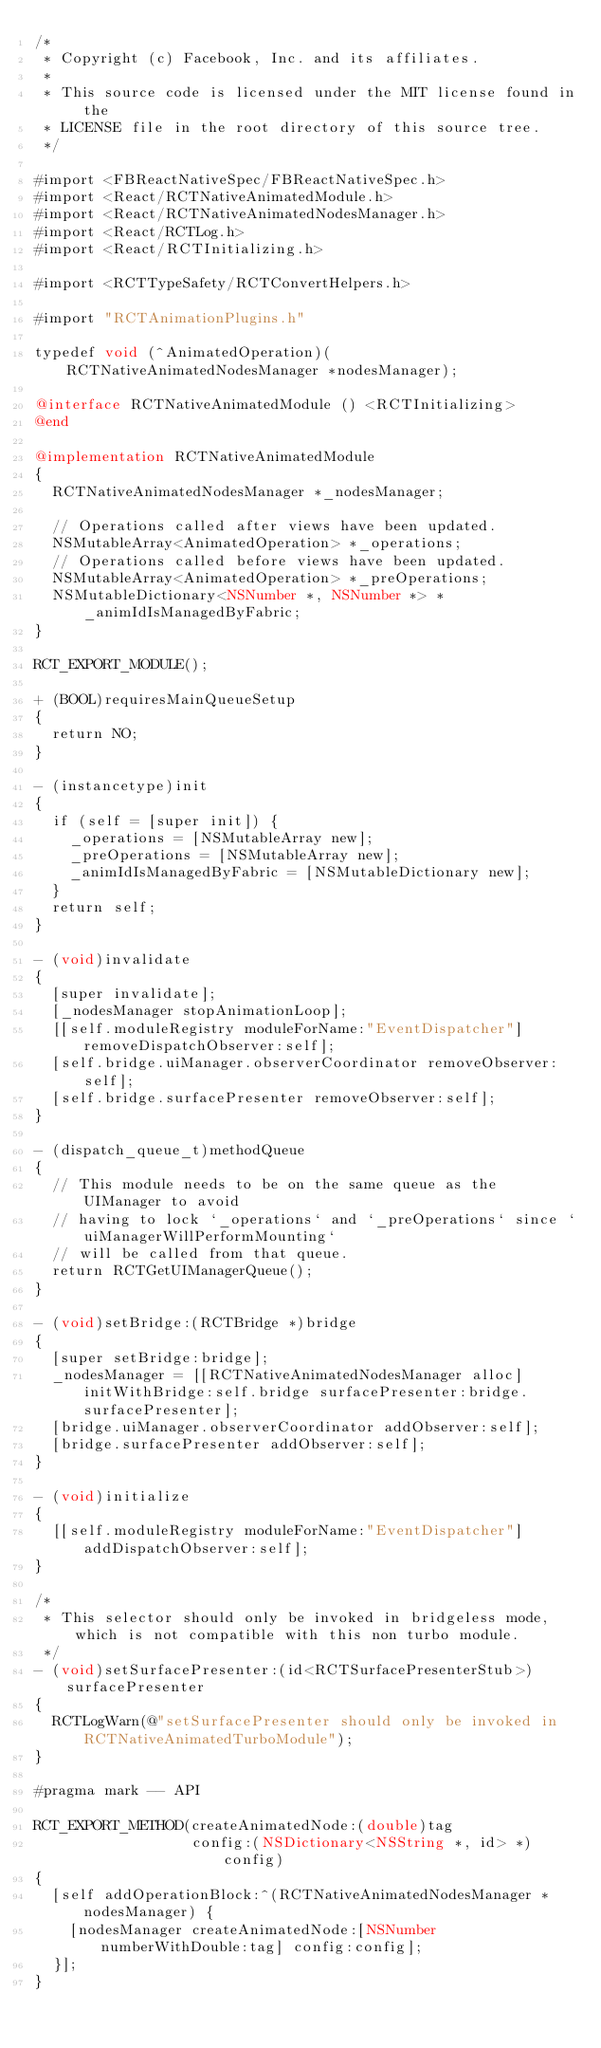<code> <loc_0><loc_0><loc_500><loc_500><_ObjectiveC_>/*
 * Copyright (c) Facebook, Inc. and its affiliates.
 *
 * This source code is licensed under the MIT license found in the
 * LICENSE file in the root directory of this source tree.
 */

#import <FBReactNativeSpec/FBReactNativeSpec.h>
#import <React/RCTNativeAnimatedModule.h>
#import <React/RCTNativeAnimatedNodesManager.h>
#import <React/RCTLog.h>
#import <React/RCTInitializing.h>

#import <RCTTypeSafety/RCTConvertHelpers.h>

#import "RCTAnimationPlugins.h"

typedef void (^AnimatedOperation)(RCTNativeAnimatedNodesManager *nodesManager);

@interface RCTNativeAnimatedModule () <RCTInitializing>
@end

@implementation RCTNativeAnimatedModule
{
  RCTNativeAnimatedNodesManager *_nodesManager;

  // Operations called after views have been updated.
  NSMutableArray<AnimatedOperation> *_operations;
  // Operations called before views have been updated.
  NSMutableArray<AnimatedOperation> *_preOperations;
  NSMutableDictionary<NSNumber *, NSNumber *> *_animIdIsManagedByFabric;
}

RCT_EXPORT_MODULE();

+ (BOOL)requiresMainQueueSetup
{
  return NO;
}

- (instancetype)init
{
  if (self = [super init]) {
    _operations = [NSMutableArray new];
    _preOperations = [NSMutableArray new];
    _animIdIsManagedByFabric = [NSMutableDictionary new];
  }
  return self;
}

- (void)invalidate
{
  [super invalidate];
  [_nodesManager stopAnimationLoop];
  [[self.moduleRegistry moduleForName:"EventDispatcher"] removeDispatchObserver:self];
  [self.bridge.uiManager.observerCoordinator removeObserver:self];
  [self.bridge.surfacePresenter removeObserver:self];
}

- (dispatch_queue_t)methodQueue
{
  // This module needs to be on the same queue as the UIManager to avoid
  // having to lock `_operations` and `_preOperations` since `uiManagerWillPerformMounting`
  // will be called from that queue.
  return RCTGetUIManagerQueue();
}

- (void)setBridge:(RCTBridge *)bridge
{
  [super setBridge:bridge];
  _nodesManager = [[RCTNativeAnimatedNodesManager alloc] initWithBridge:self.bridge surfacePresenter:bridge.surfacePresenter];
  [bridge.uiManager.observerCoordinator addObserver:self];
  [bridge.surfacePresenter addObserver:self];
}

- (void)initialize
{
  [[self.moduleRegistry moduleForName:"EventDispatcher"] addDispatchObserver:self];
}

/*
 * This selector should only be invoked in bridgeless mode, which is not compatible with this non turbo module.
 */
- (void)setSurfacePresenter:(id<RCTSurfacePresenterStub>)surfacePresenter
{
  RCTLogWarn(@"setSurfacePresenter should only be invoked in RCTNativeAnimatedTurboModule");
}

#pragma mark -- API

RCT_EXPORT_METHOD(createAnimatedNode:(double)tag
                  config:(NSDictionary<NSString *, id> *)config)
{
  [self addOperationBlock:^(RCTNativeAnimatedNodesManager *nodesManager) {
    [nodesManager createAnimatedNode:[NSNumber numberWithDouble:tag] config:config];
  }];
}
</code> 